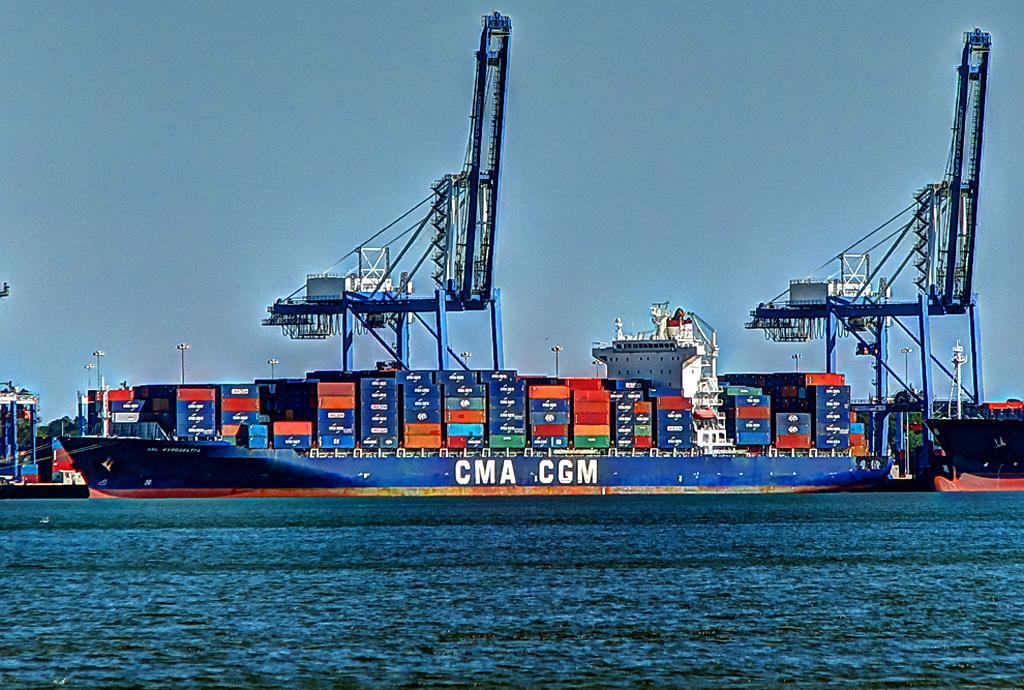Please provide a concise description of this image. At the bottom of this image I can see the water. In the background there is a cargo ship, two containers and a building. At the top of the image I can see the sky. On the left side there are few poles. 